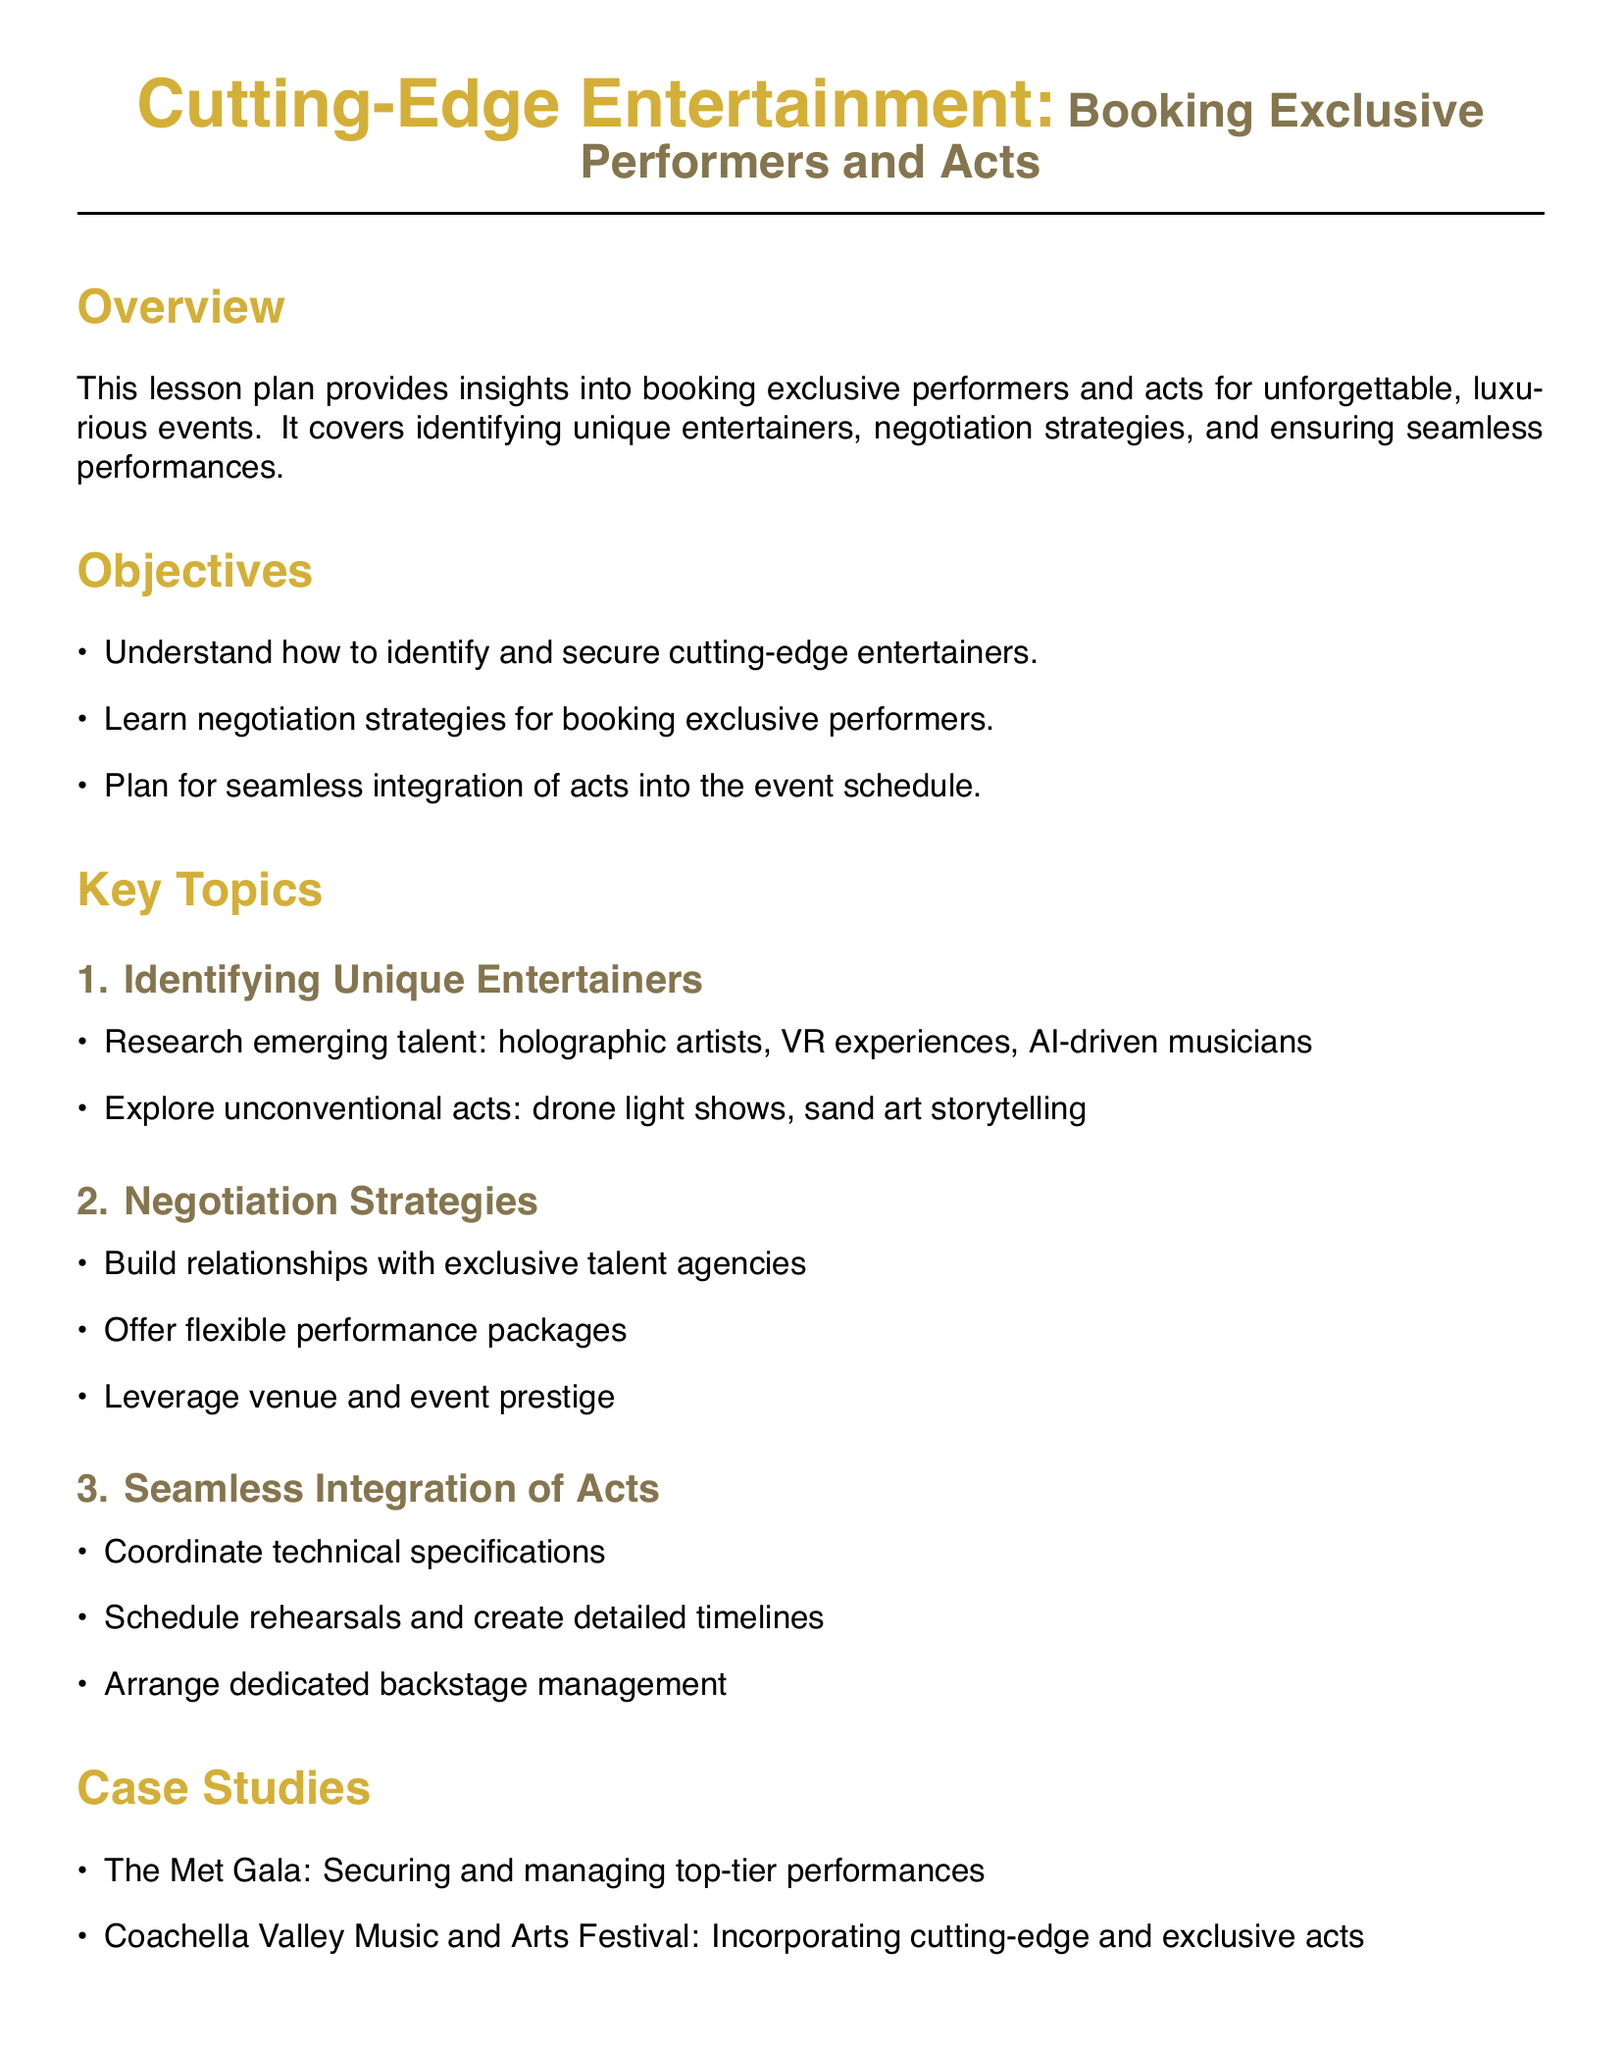What are the key objectives of the lesson plan? The objectives outline what participants will learn, including identifying entertainers, negotiation strategies, and planning performances.
Answer: Understand how to identify and secure cutting-edge entertainers, learn negotiation strategies for booking exclusive performers, plan for seamless integration of acts into the event schedule What is one unconventional act mentioned in the document? The document lists examples of unconventional acts under unique entertainers, providing specific types of performances that enhance guest experiences.
Answer: Drone light shows What is the recommended reading titled by Mark Sonder? The title of the book authored by Mark Sonder is mentioned in the resources section, focusing on the event entertainment and production field.
Answer: Event Entertainment and Production What type of acts does the lesson plan focus on? The lesson plan aims to provide guidance on securing performers who offer innovative and exclusive experiences for high-profile events.
Answer: Exclusive performers Which festival is mentioned as a case study in the document? The document provides examples of high-profile events that have incorporated exclusive performers, specifying one well-known festival to illustrate successful practices.
Answer: Coachella Valley Music and Arts Festival What is suggested as a strategy for negotiating with talent agencies? The document outlines effective practices for securing exclusive performers, suggesting strategies that can strengthen relationships and outcomes.
Answer: Build relationships with exclusive talent agencies How many key topics are covered in the lesson plan? The document structures its content into distinct sections, summarizing the critical areas of focus in booking entertainment.
Answer: Three What is one resource specified for event managers? The document recommends websites that could assist in planning and managing events, which are listed in the resources section.
Answer: Pollstar 